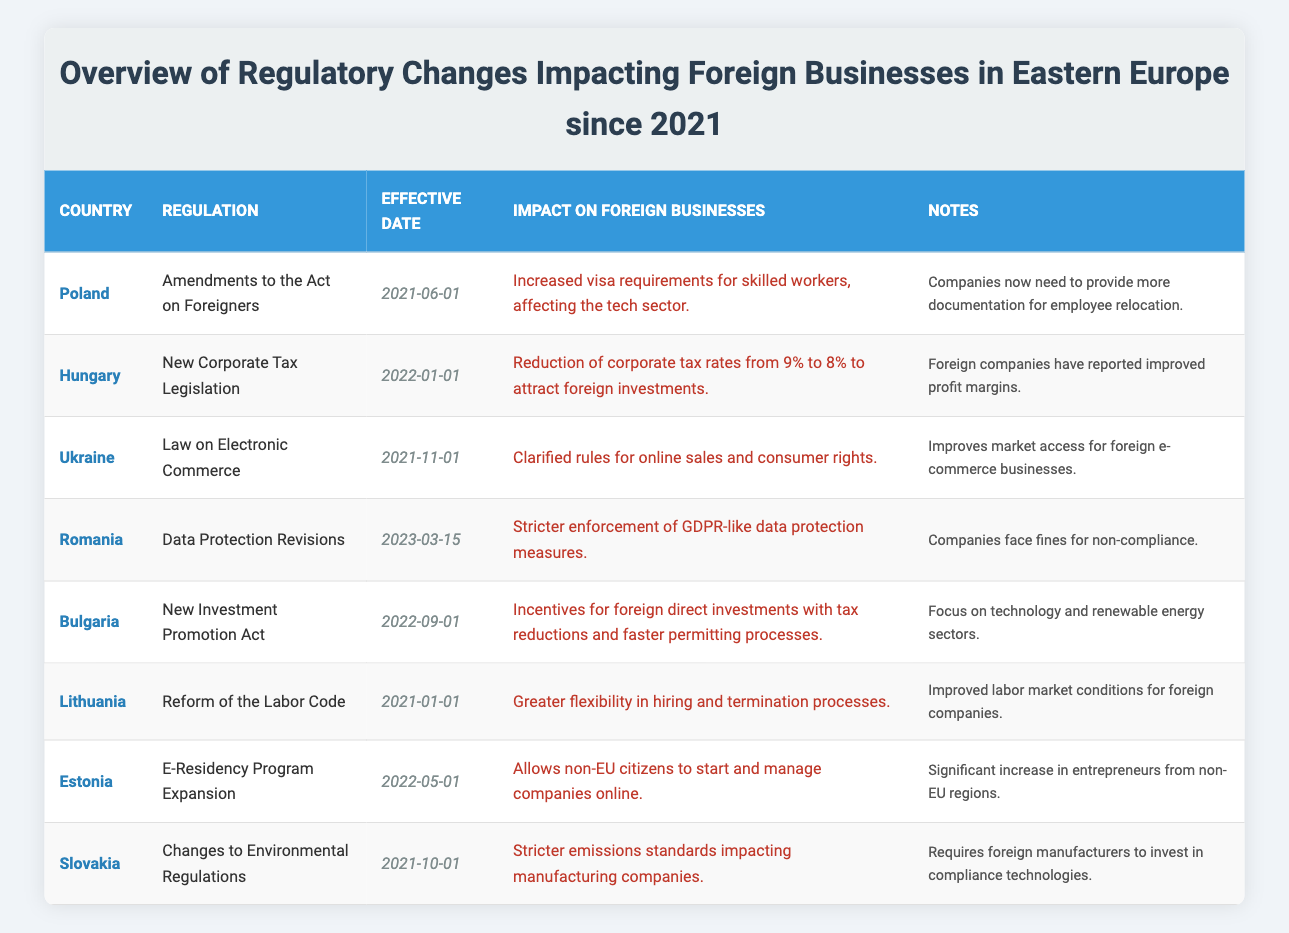What regulation was implemented in Poland on June 1, 2021? The table lists "Amendments to the Act on Foreigners" as the regulation effective in Poland on that date.
Answer: Amendments to the Act on Foreigners How many countries introduced regulations impacting foreign businesses in 2022? Based on the table, there are three entries for 2022: Hungary (New Corporate Tax Legislation), Bulgaria (New Investment Promotion Act), and Estonia (E-Residency Program Expansion).
Answer: Three Did Romania introduce stricter data protection measures since 2023? The table indicates that Romania revised its data protection laws with stricter enforcement of GDPR-like measures beginning on March 15, 2023, thus confirming the fact.
Answer: Yes What is the primary incentive provided by Bulgaria's New Investment Promotion Act? The table states that the act offers incentives for foreign direct investments, specifically focusing on tax reductions and faster permitting processes, benefiting foreign businesses.
Answer: Tax reductions and faster permitting processes Which country implemented a law to clarify e-commerce rules for foreign businesses, and when? The table shows that Ukraine implemented the "Law on Electronic Commerce" on November 1, 2021, to clarify rules for online sales and consumer rights.
Answer: Ukraine; November 1, 2021 How does the new corporate tax legislation in Hungary affect foreign companies' profit margins? Hungary's introduction of a new corporate tax rate reduces it from 9% to 8%, which has allowed foreign companies to report improved profit margins, as indicated in the table.
Answer: Improved profit margins What is the impact of stricter emissions standards in Slovakia? The table notes that changes to environmental regulations impose stricter emissions standards, which require foreign manufacturers to invest in compliance technologies, presenting operational challenges for those companies.
Answer: Requires investment in compliance technologies What countries have implemented regulations related to labor laws since January 1, 2021? The table reveals that Lithuania enacted a reform of the Labor Code effective January 1, 2021, which enhances hiring and termination processes, focusing on labor market conditions for foreign companies.
Answer: Lithuania What regulation allows non-EU citizens to start and manage companies online, and when was it effective? According to the table, Estonia's E-Residency Program Expansion allows non-EU citizens to start and manage companies online, effective from May 1, 2022.
Answer: E-Residency Program Expansion; May 1, 2022 